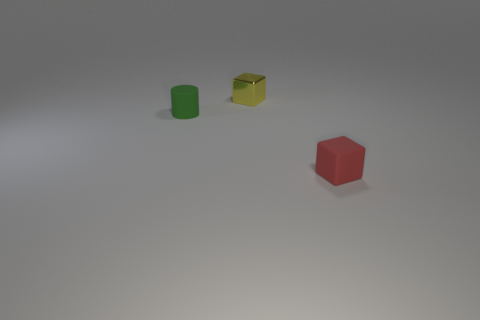Is there any object that appears to have a reflective surface? Yes, the yellow cube in the image has a reflective surface. Unlike the matte finish of the green cylinder and the red cube, the yellow cube has a shinier appearance that seems to reflect some light, which suggests it might be of a different material. 